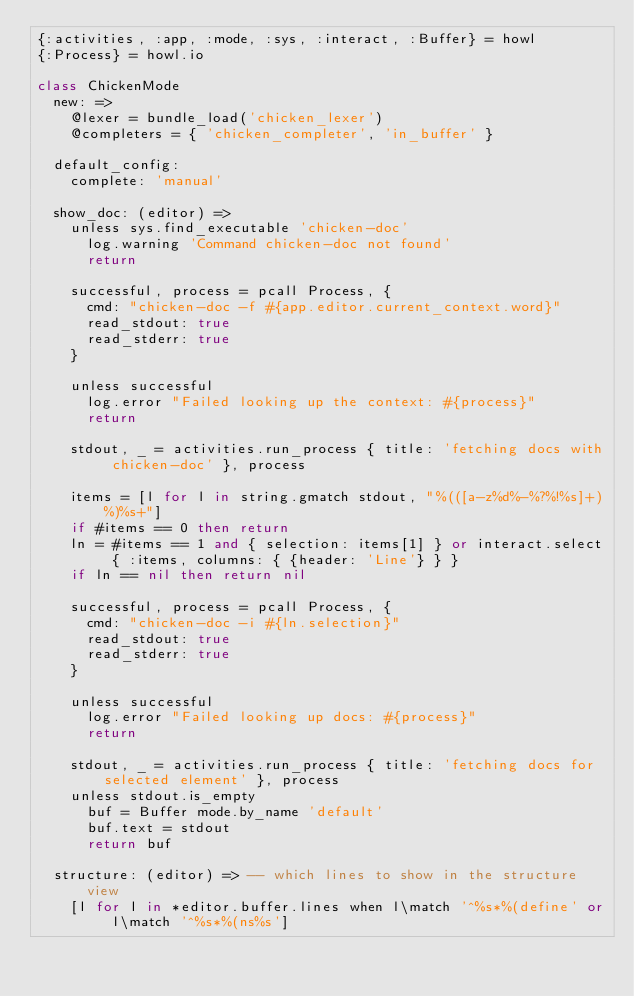<code> <loc_0><loc_0><loc_500><loc_500><_MoonScript_>{:activities, :app, :mode, :sys, :interact, :Buffer} = howl
{:Process} = howl.io

class ChickenMode
  new: =>
    @lexer = bundle_load('chicken_lexer')
    @completers = { 'chicken_completer', 'in_buffer' }

  default_config:
    complete: 'manual'

  show_doc: (editor) =>
    unless sys.find_executable 'chicken-doc'
      log.warning 'Command chicken-doc not found'
      return

    successful, process = pcall Process, {
      cmd: "chicken-doc -f #{app.editor.current_context.word}"
      read_stdout: true
      read_stderr: true
    }

    unless successful
      log.error "Failed looking up the context: #{process}"
      return

    stdout, _ = activities.run_process { title: 'fetching docs with chicken-doc' }, process

    items = [l for l in string.gmatch stdout, "%(([a-z%d%-%?%!%s]+)%)%s+"]
    if #items == 0 then return
    ln = #items == 1 and { selection: items[1] } or interact.select { :items, columns: { {header: 'Line'} } }
    if ln == nil then return nil

    successful, process = pcall Process, {
      cmd: "chicken-doc -i #{ln.selection}"
      read_stdout: true
      read_stderr: true
    }

    unless successful
      log.error "Failed looking up docs: #{process}"
      return

    stdout, _ = activities.run_process { title: 'fetching docs for selected element' }, process
    unless stdout.is_empty
      buf = Buffer mode.by_name 'default'
      buf.text = stdout
      return buf

  structure: (editor) => -- which lines to show in the structure view
    [l for l in *editor.buffer.lines when l\match '^%s*%(define' or l\match '^%s*%(ns%s']
</code> 